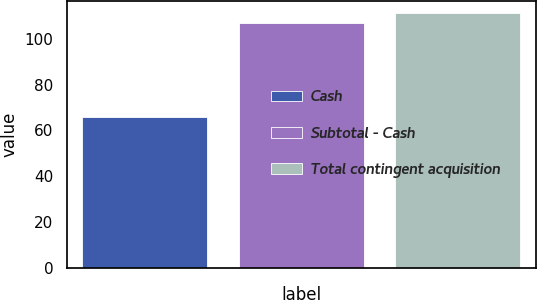<chart> <loc_0><loc_0><loc_500><loc_500><bar_chart><fcel>Cash<fcel>Subtotal - Cash<fcel>Total contingent acquisition<nl><fcel>65.8<fcel>106.8<fcel>111.2<nl></chart> 